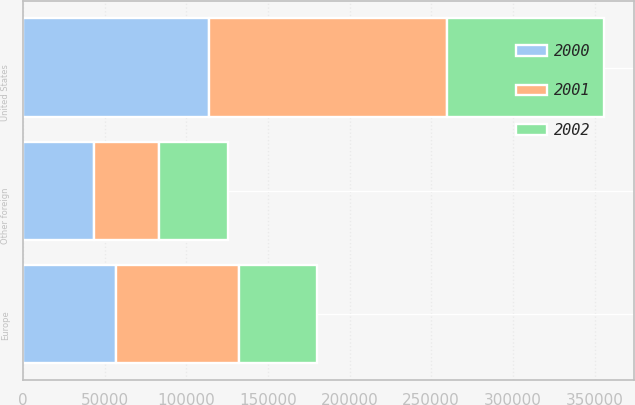<chart> <loc_0><loc_0><loc_500><loc_500><stacked_bar_chart><ecel><fcel>United States<fcel>Europe<fcel>Other foreign<nl><fcel>2001<fcel>146247<fcel>75205<fcel>39628<nl><fcel>2000<fcel>113683<fcel>57206<fcel>43484<nl><fcel>2002<fcel>96140<fcel>47668<fcel>42549<nl></chart> 